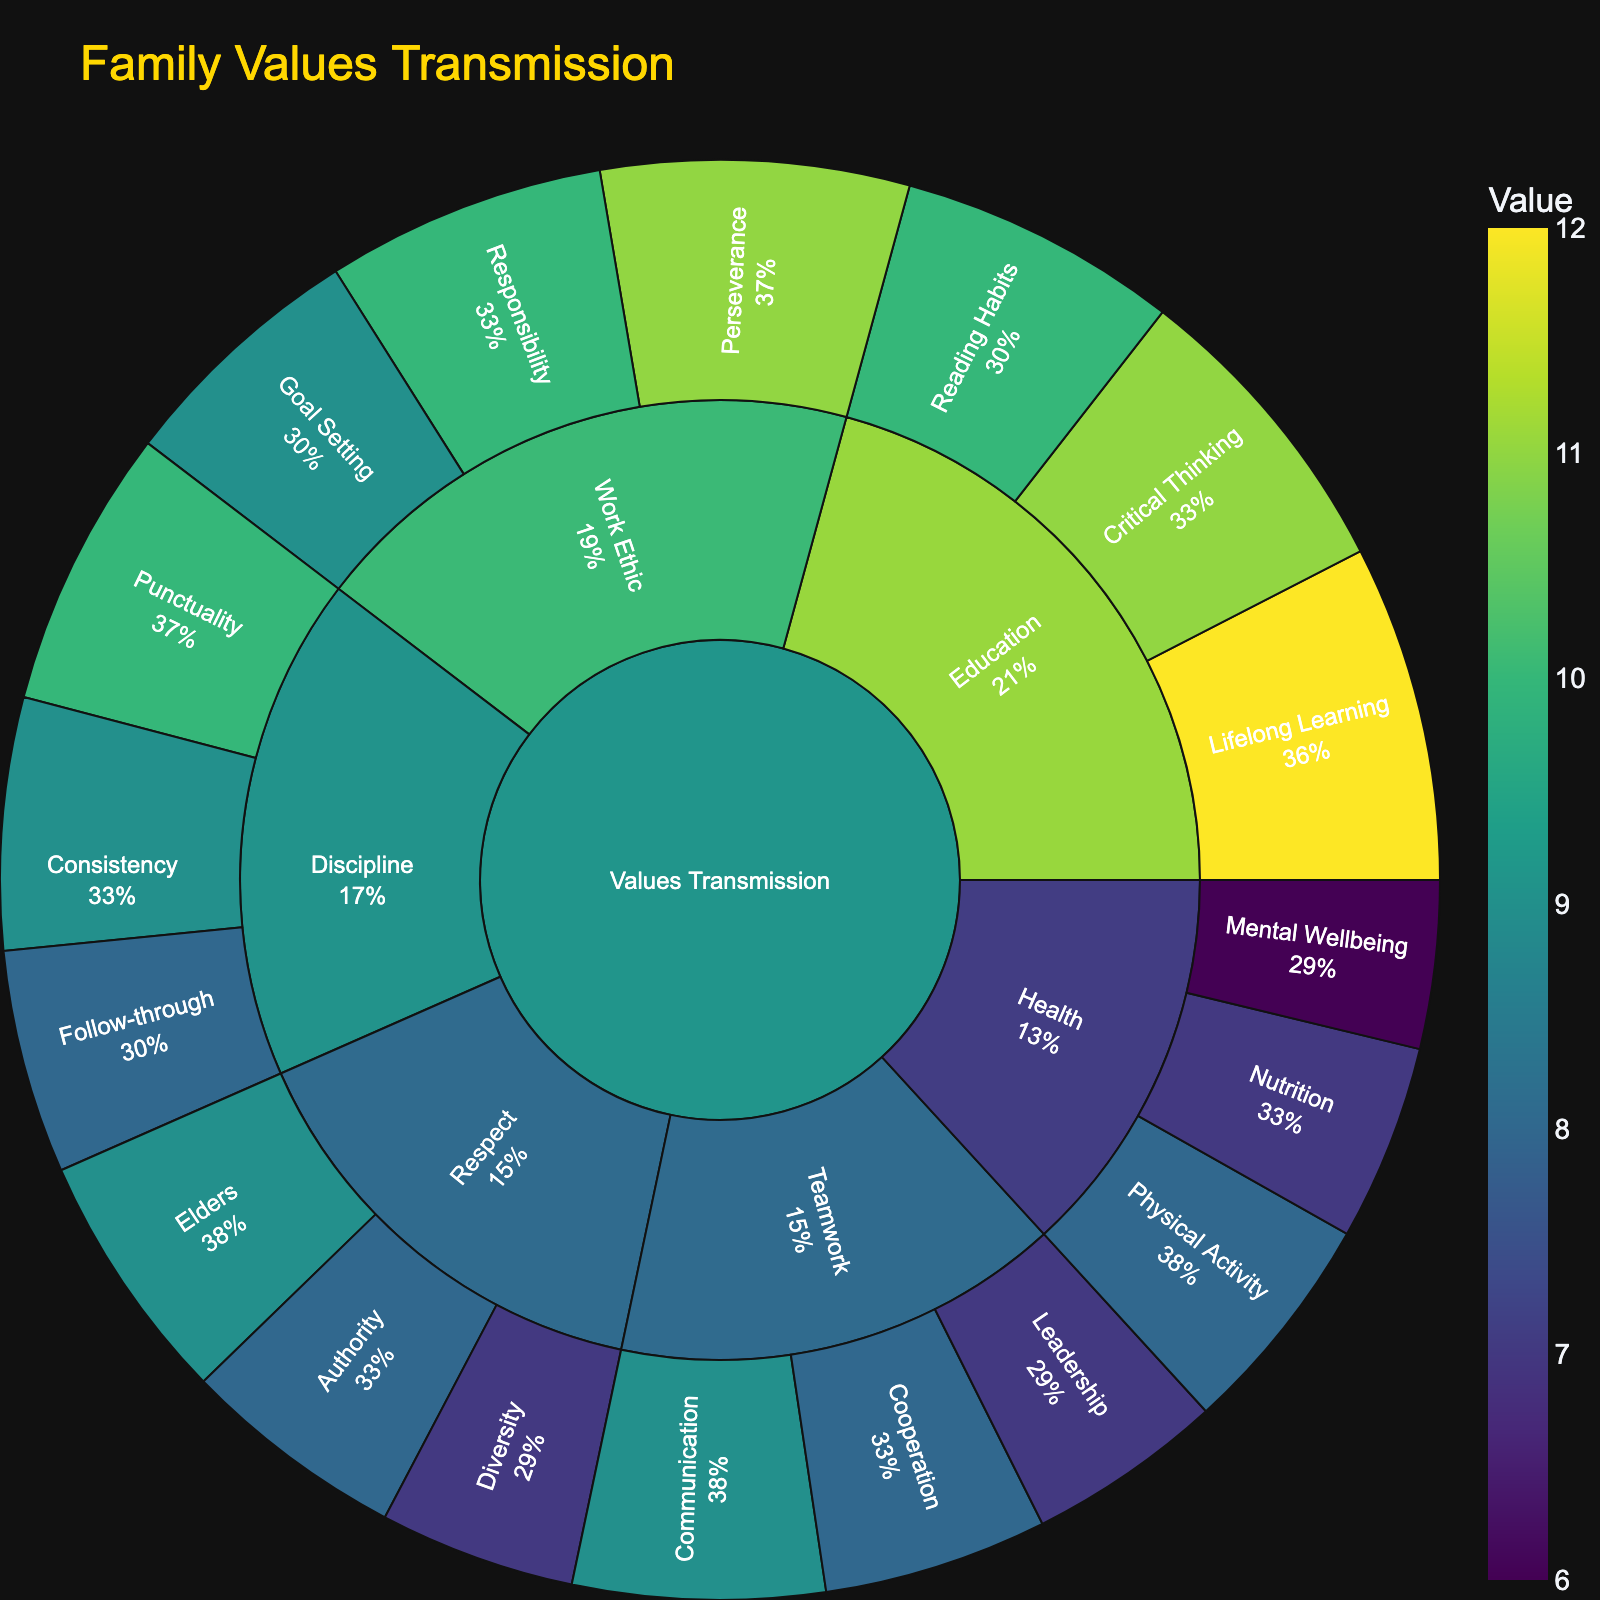What's the title of the plot? The title of the plot is typically located at the top center of the figure. It summarizes what the plot represents. In this case, the title is "Family Values Transmission".
Answer: Family Values Transmission How many core principles are shown in the sunburst plot? The core principles are represented by the first ring of categories branching out from the center. These core principles are: Discipline, Education, Respect, Work Ethic, Teamwork, and Health. Counting these principles gives us the total.
Answer: 6 Which subcategory within 'Discipline' has the highest value? We need to look at the segments under the 'Discipline' category and compare their values. Punctuality (10), Follow-through (8), and Consistency (9). The subcategory Punctuality has the highest value.
Answer: Punctuality What is the combined value of all subcategories under 'Health'? We sum the values of the 'Health' subcategories: Physical Activity (8), Nutrition (7), and Mental Wellbeing (6). Therefore, 8 + 7 + 6 = 21.
Answer: 21 Which subcategory in 'Education' has the lowest value compared to the others? By comparing values of subcategories under 'Education' - Lifelong Learning (12), Critical Thinking (11), and Reading Habits (10) - Reading Habits has the lowest value.
Answer: Reading Habits How does the value of 'Cooperation' in 'Teamwork' compare to 'Elders' in 'Respect'? We need to look at the values of 'Cooperation' (8) and 'Elders' (9) to compare them. 'Elders' has a higher value than 'Cooperation'.
Answer: Elders > Cooperation What percentage of 'Discipline' does 'Punctuality' represent? To find this, we sum the values within 'Discipline': Punctuality (10), Follow-through (8), and Consistency (9). The total value is 27. The percentage is (10/27) * 100 ≈ 37%.
Answer: ~37% Which has more subcategories, 'Education' or 'Work Ethic'? We count the subcategories under each main category. 'Education' has Lifelong Learning, Critical Thinking, and Reading Habits (3), while 'Work Ethic' has Perseverance, Responsibility, and Goal Setting (3). Both have the same number.
Answer: Equal What is the total value represented by the 'Respect' category? Add the values of the subcategories under 'Respect': Elders (9), Authority (8), and Diversity (7). Therefore, 9 + 8 + 7 = 24.
Answer: 24 Which has a higher value, 'Physical Activity' under 'Health' or 'Leadership' under 'Teamwork'? Compare the values of 'Physical Activity' (8) and 'Leadership' (7) to see which is higher. Physical Activity has a higher value.
Answer: Physical Activity 